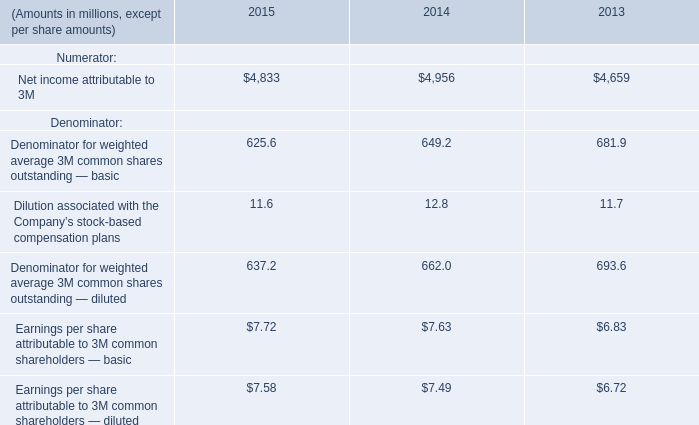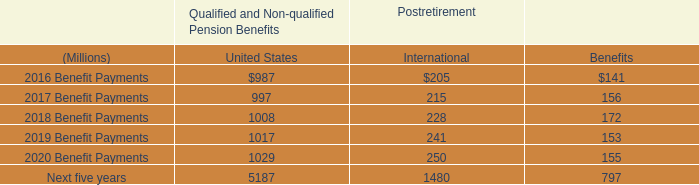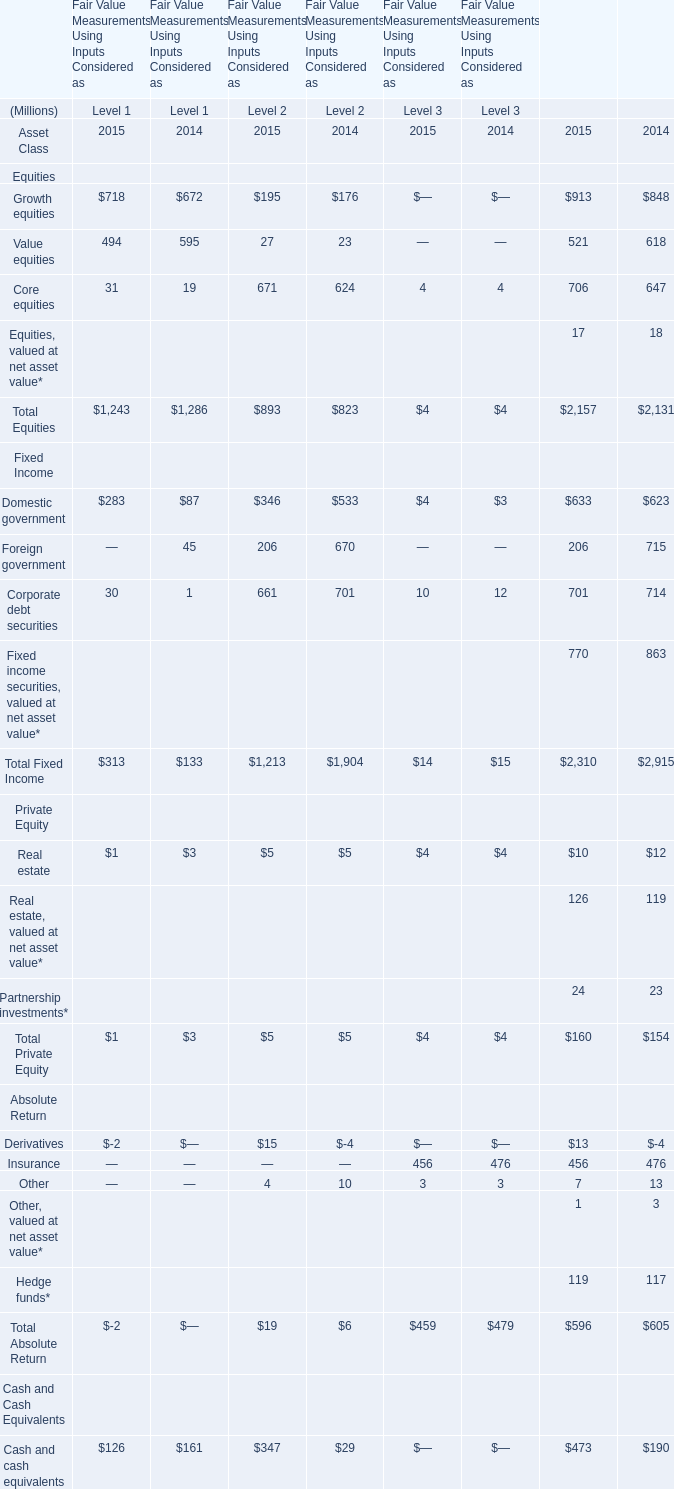what was the ratio of the company contribution to the us qualified and non-qualified pension benefits for 2015 compared to 2014 
Computations: (264 / 210)
Answer: 1.25714. 